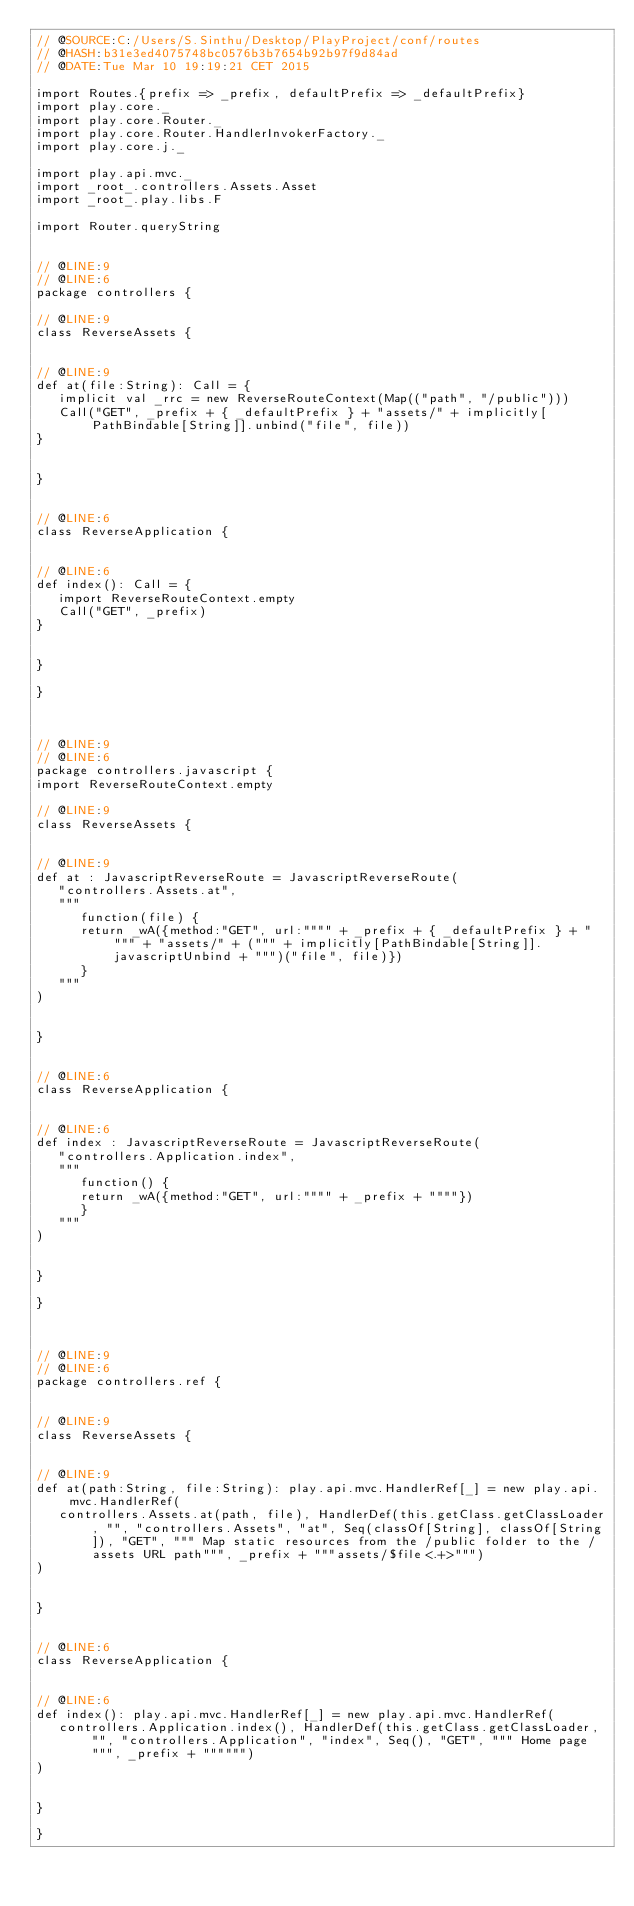Convert code to text. <code><loc_0><loc_0><loc_500><loc_500><_Scala_>// @SOURCE:C:/Users/S.Sinthu/Desktop/PlayProject/conf/routes
// @HASH:b31e3ed4075748bc0576b3b7654b92b97f9d84ad
// @DATE:Tue Mar 10 19:19:21 CET 2015

import Routes.{prefix => _prefix, defaultPrefix => _defaultPrefix}
import play.core._
import play.core.Router._
import play.core.Router.HandlerInvokerFactory._
import play.core.j._

import play.api.mvc._
import _root_.controllers.Assets.Asset
import _root_.play.libs.F

import Router.queryString


// @LINE:9
// @LINE:6
package controllers {

// @LINE:9
class ReverseAssets {


// @LINE:9
def at(file:String): Call = {
   implicit val _rrc = new ReverseRouteContext(Map(("path", "/public")))
   Call("GET", _prefix + { _defaultPrefix } + "assets/" + implicitly[PathBindable[String]].unbind("file", file))
}
                        

}
                          

// @LINE:6
class ReverseApplication {


// @LINE:6
def index(): Call = {
   import ReverseRouteContext.empty
   Call("GET", _prefix)
}
                        

}
                          
}
                  


// @LINE:9
// @LINE:6
package controllers.javascript {
import ReverseRouteContext.empty

// @LINE:9
class ReverseAssets {


// @LINE:9
def at : JavascriptReverseRoute = JavascriptReverseRoute(
   "controllers.Assets.at",
   """
      function(file) {
      return _wA({method:"GET", url:"""" + _prefix + { _defaultPrefix } + """" + "assets/" + (""" + implicitly[PathBindable[String]].javascriptUnbind + """)("file", file)})
      }
   """
)
                        

}
              

// @LINE:6
class ReverseApplication {


// @LINE:6
def index : JavascriptReverseRoute = JavascriptReverseRoute(
   "controllers.Application.index",
   """
      function() {
      return _wA({method:"GET", url:"""" + _prefix + """"})
      }
   """
)
                        

}
              
}
        


// @LINE:9
// @LINE:6
package controllers.ref {


// @LINE:9
class ReverseAssets {


// @LINE:9
def at(path:String, file:String): play.api.mvc.HandlerRef[_] = new play.api.mvc.HandlerRef(
   controllers.Assets.at(path, file), HandlerDef(this.getClass.getClassLoader, "", "controllers.Assets", "at", Seq(classOf[String], classOf[String]), "GET", """ Map static resources from the /public folder to the /assets URL path""", _prefix + """assets/$file<.+>""")
)
                      

}
                          

// @LINE:6
class ReverseApplication {


// @LINE:6
def index(): play.api.mvc.HandlerRef[_] = new play.api.mvc.HandlerRef(
   controllers.Application.index(), HandlerDef(this.getClass.getClassLoader, "", "controllers.Application", "index", Seq(), "GET", """ Home page""", _prefix + """""")
)
                      

}
                          
}
        
    </code> 